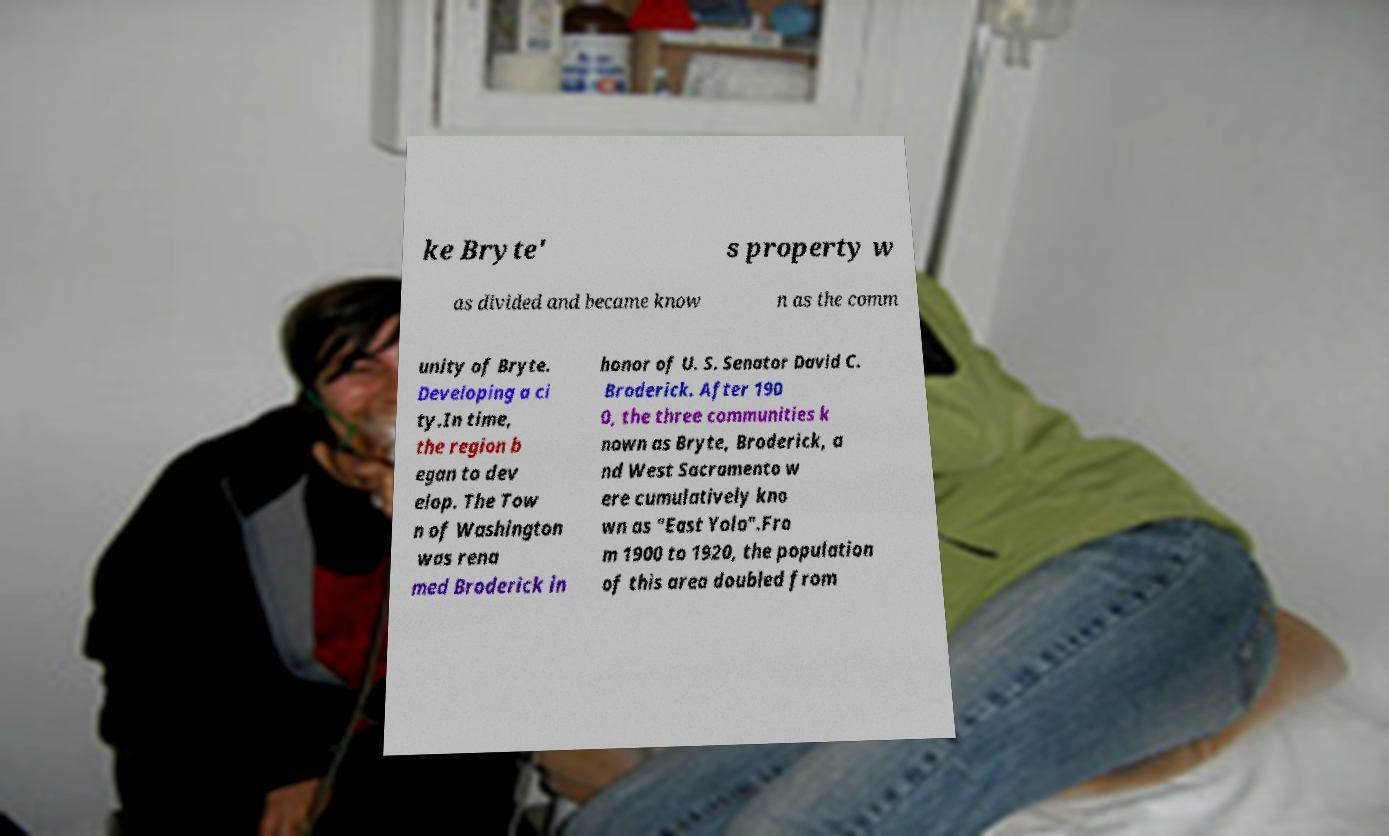For documentation purposes, I need the text within this image transcribed. Could you provide that? ke Bryte' s property w as divided and became know n as the comm unity of Bryte. Developing a ci ty.In time, the region b egan to dev elop. The Tow n of Washington was rena med Broderick in honor of U. S. Senator David C. Broderick. After 190 0, the three communities k nown as Bryte, Broderick, a nd West Sacramento w ere cumulatively kno wn as "East Yolo".Fro m 1900 to 1920, the population of this area doubled from 